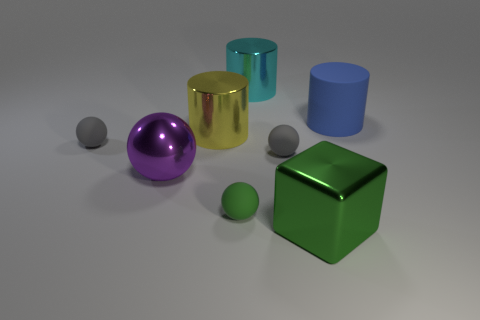Subtract all cyan cylinders. How many cylinders are left? 2 Subtract all gray spheres. How many spheres are left? 2 Subtract all cubes. How many objects are left? 7 Add 2 small red matte things. How many small red matte things exist? 2 Add 2 large green metal blocks. How many objects exist? 10 Subtract 0 cyan blocks. How many objects are left? 8 Subtract 1 blocks. How many blocks are left? 0 Subtract all cyan spheres. Subtract all red blocks. How many spheres are left? 4 Subtract all red spheres. How many cyan cylinders are left? 1 Subtract all big gray metal cubes. Subtract all yellow metallic objects. How many objects are left? 7 